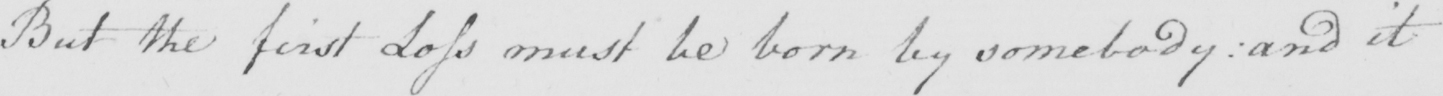Can you read and transcribe this handwriting? But the first Loss must be born by somebody :  and it 